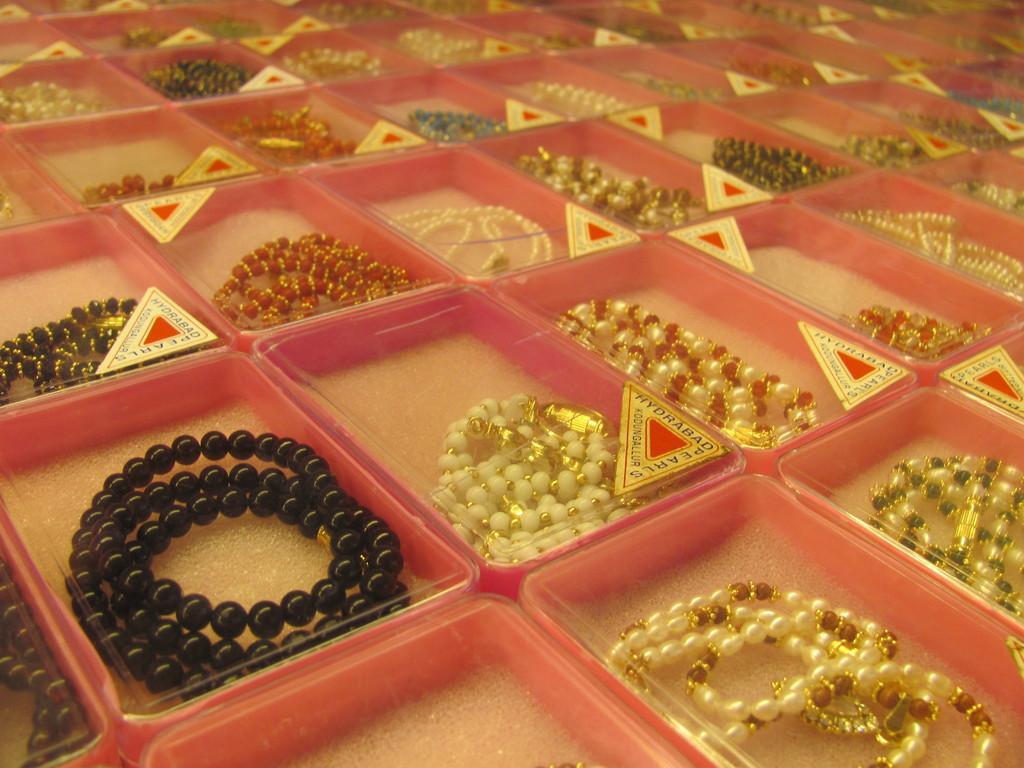In one or two sentences, can you explain what this image depicts? This image consists of ornaments kept in the boxes. 